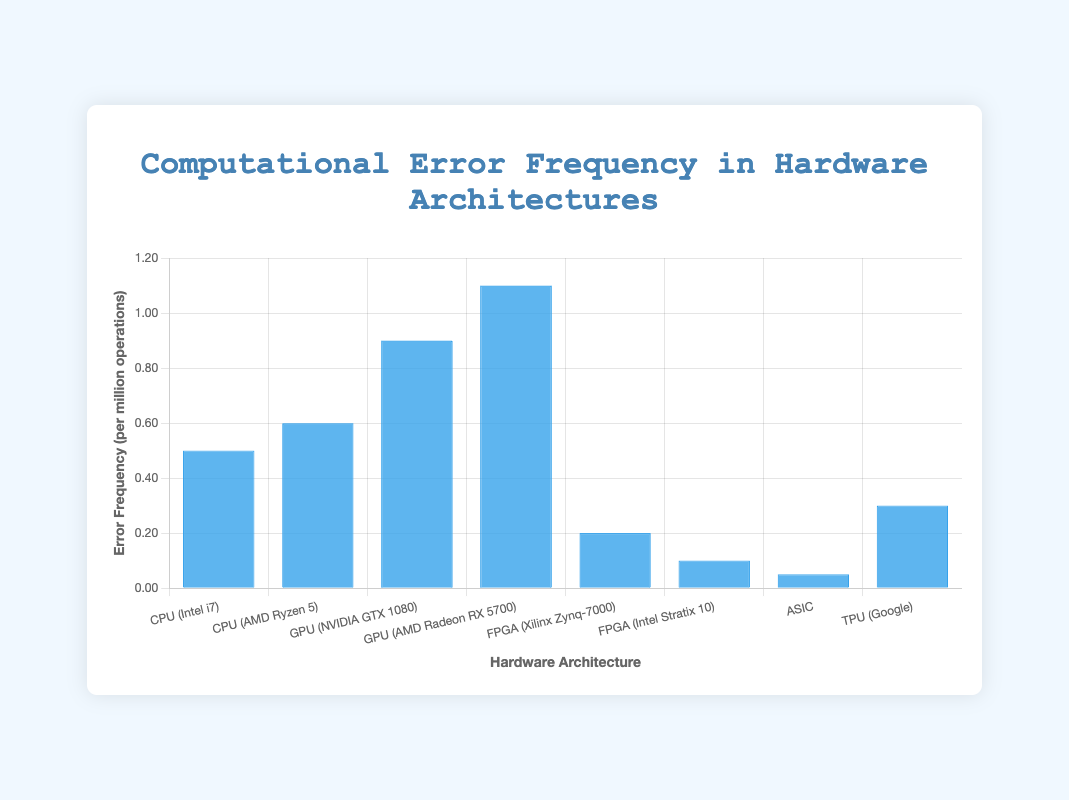Which hardware architecture has the highest error frequency and what is its value? The bar representing "GPU (AMD Radeon RX 5700)" is the tallest in the plot, indicating it has the highest error frequency. The value for this architecture is 1.1 errors per million operations.
Answer: GPU (AMD Radeon RX 5700), 1.1 Which hardware architecture has the lowest error frequency? The shortest bar represents "ASIC (Application-Specific Integrated Circuit)", indicating it has the lowest error frequency of 0.05 errors per million operations.
Answer: ASIC (Application-Specific Integrated Circuit) What is the difference in error frequency between the highest and lowest error frequencies? The highest error frequency is 1.1 (GPU AMD Radeon RX 5700) and the lowest is 0.05 (ASIC). The difference is calculated as 1.1 - 0.05 = 1.05.
Answer: 1.05 How many hardware architectures have an error frequency higher than 0.5 per million operations? By examining the figure, the architectures with error frequencies above 0.5 are: "CPU (AMD Ryzen 5)", "GPU (NVIDIA GTX 1080)", and "GPU (AMD Radeon RX 5700)". Hence, the number is 3.
Answer: 3 Which CPU architecture has a lower error frequency, Intel i7 or AMD Ryzen 5? The bar for "CPU (Intel i7)" is shorter than the bar for "CPU (AMD Ryzen 5)", meaning Intel i7 has a lower error frequency of 0.5 compared to AMD Ryzen 5's 0.6.
Answer: CPU (Intel i7) What is the combined error frequency of both FPGA architectures? Summing up the error frequencies for "FPGA (Xilinx Zynq-7000)" and "FPGA (Intel Stratix 10)", we get 0.2 + 0.1 = 0.3 errors per million operations.
Answer: 0.3 Compare the error frequencies of GPU (NVIDIA GTX 1080) and TPU (Google). Which is higher and by how much? The error frequency for "GPU (NVIDIA GTX 1080)" is 0.9 and for "TPU (Google)" is 0.3. The difference is calculated as 0.9 - 0.3 = 0.6, making the GPU error frequency higher by 0.6.
Answer: GPU (NVIDIA GTX 1080), 0.6 What is the average error frequency across all hardware architectures? Adding up all the error frequencies: 0.5 (CPU Intel i7) + 0.6 (CPU AMD Ryzen 5) + 0.9 (GPU NVIDIA GTX 1080) + 1.1 (GPU AMD Radeon RX 5700) + 0.2 (FPGA Xilinx Zynq-7000) + 0.1 (FPGA Intel Stratix 10) + 0.05 (ASIC) + 0.3 (TPU Google) = 3.75. Divide by the number of architectures, which is 8. The average is 3.75 / 8 = 0.46875.
Answer: 0.46875 